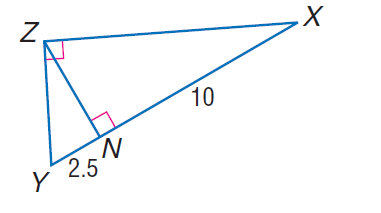Question: Find the measure of the altitude drawn to the hypotenuse.
Choices:
A. \sqrt { 2.5 }
B. 2
C. \sqrt { 10 }
D. 5
Answer with the letter. Answer: D 